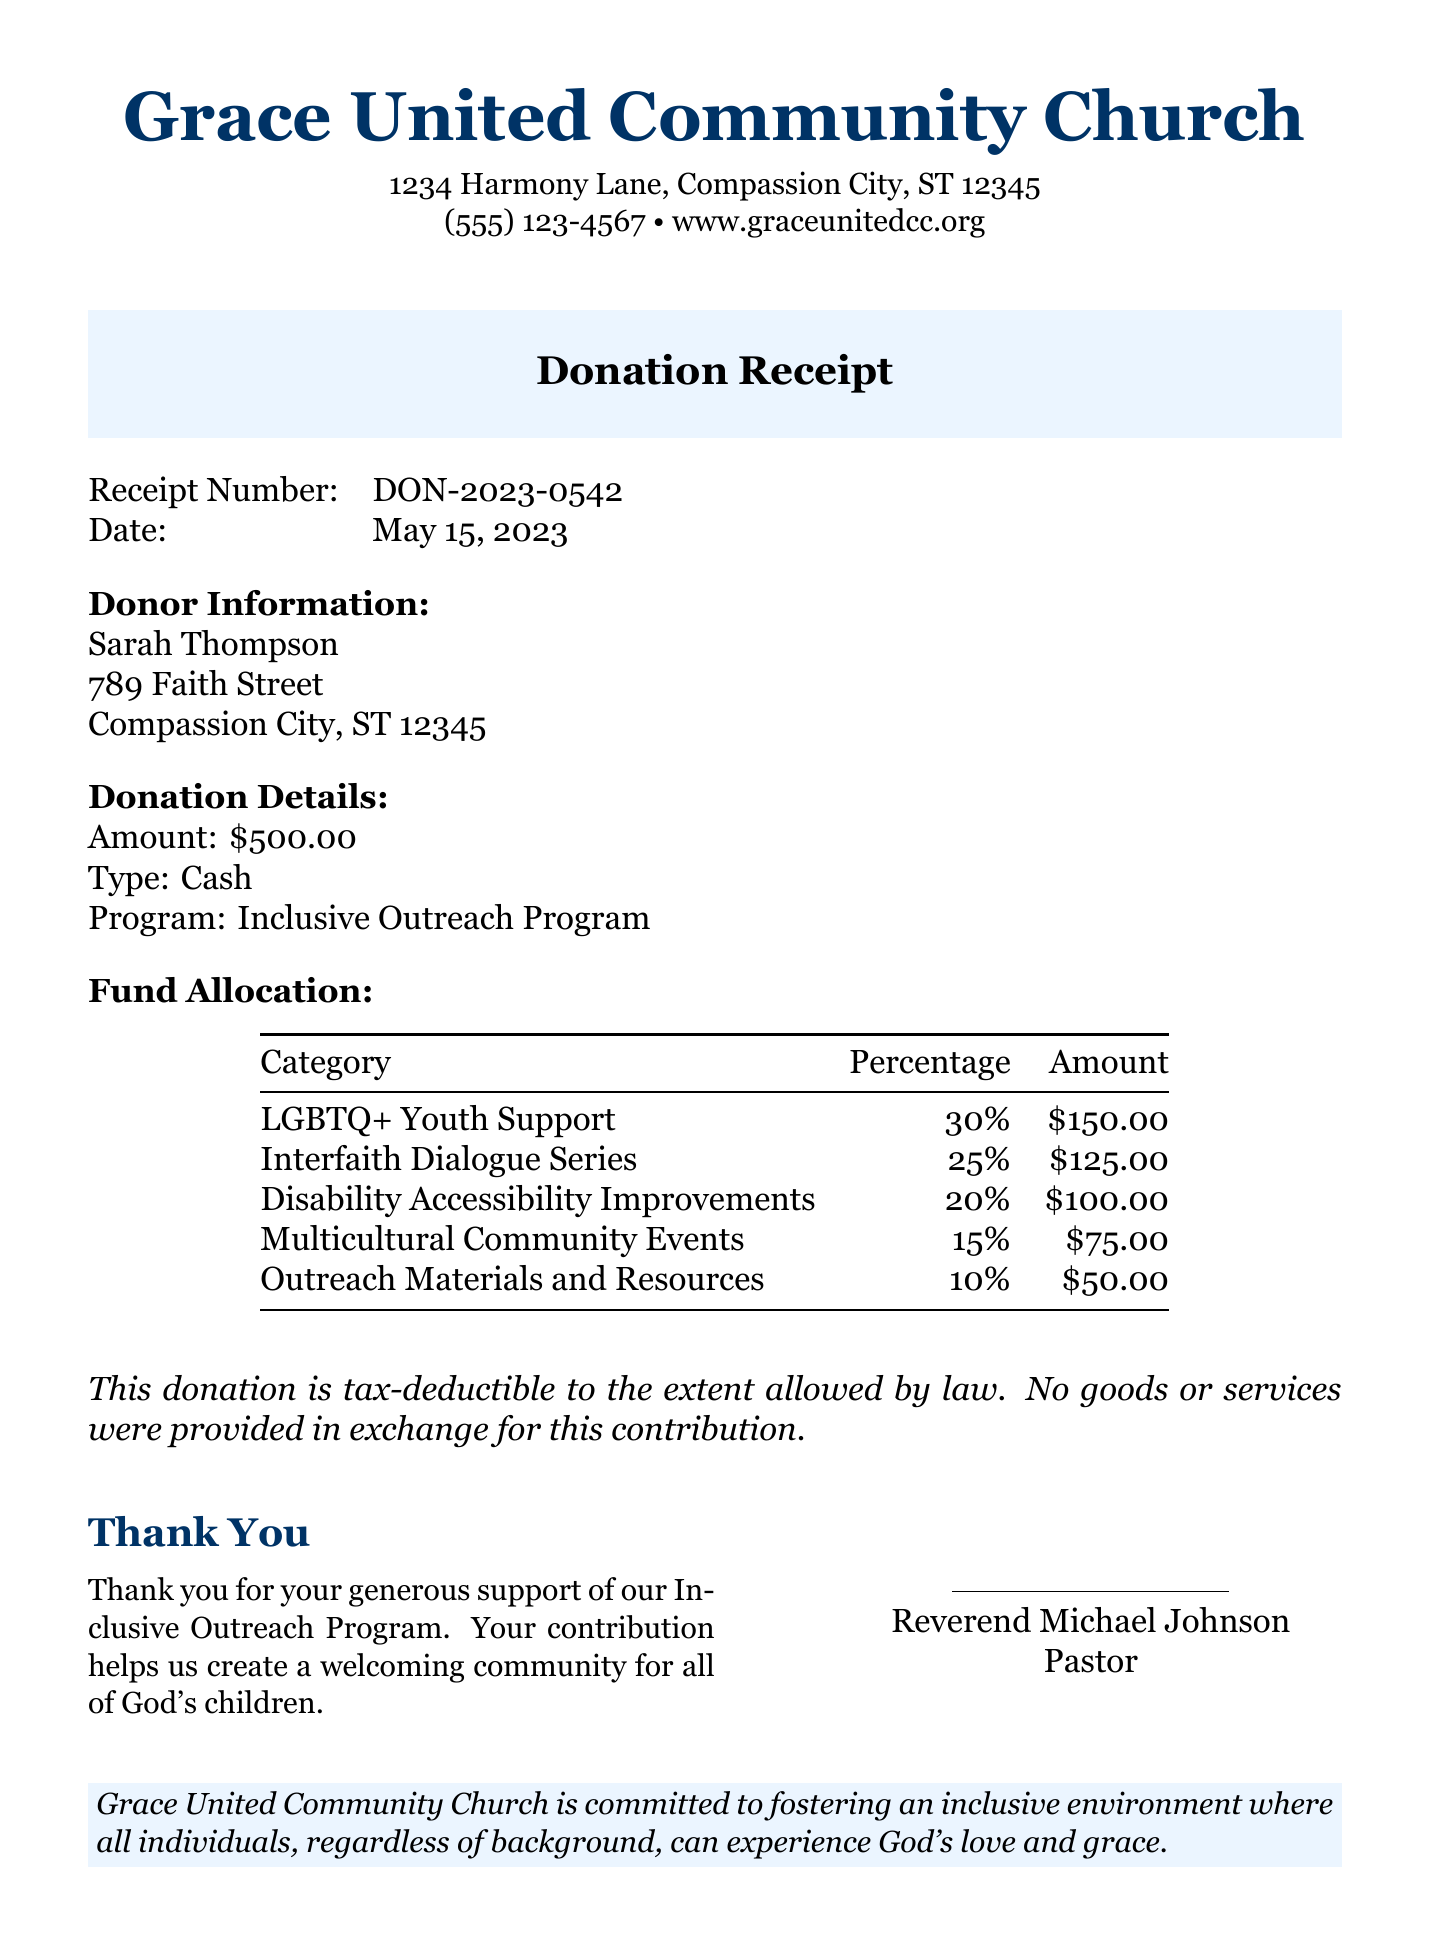What is the name of the church? The name of the church is clearly stated at the beginning of the document.
Answer: Grace United Community Church What is the donation amount? The total donation amount is specified under Donation Details.
Answer: $500.00 Who is the pastor? The pastor's name is mentioned at the bottom of the document.
Answer: Reverend Michael Johnson What program is the donation supporting? The document specifies the program for which the donation is given.
Answer: Inclusive Outreach Program What percentage of funds is allocated to LGBTQ+ Youth Support? The allocation for LGBTQ+ Youth Support can be found in the Fund Allocation table.
Answer: 30% What is the total amount allocated for Interfaith Dialogue Series? The total for Interfaith Dialogue Series is detailed in the Fund Allocation section.
Answer: $125.00 How many categories are mentioned in the fund allocation? The Fund Allocation section lists various categories that the donation will support.
Answer: 5 What is the date of the donation? The date is clearly indicated in the receipt details.
Answer: May 15, 2023 Is the donation tax-deductible? The document includes a statement regarding the tax-deductibility of the donation.
Answer: Yes 